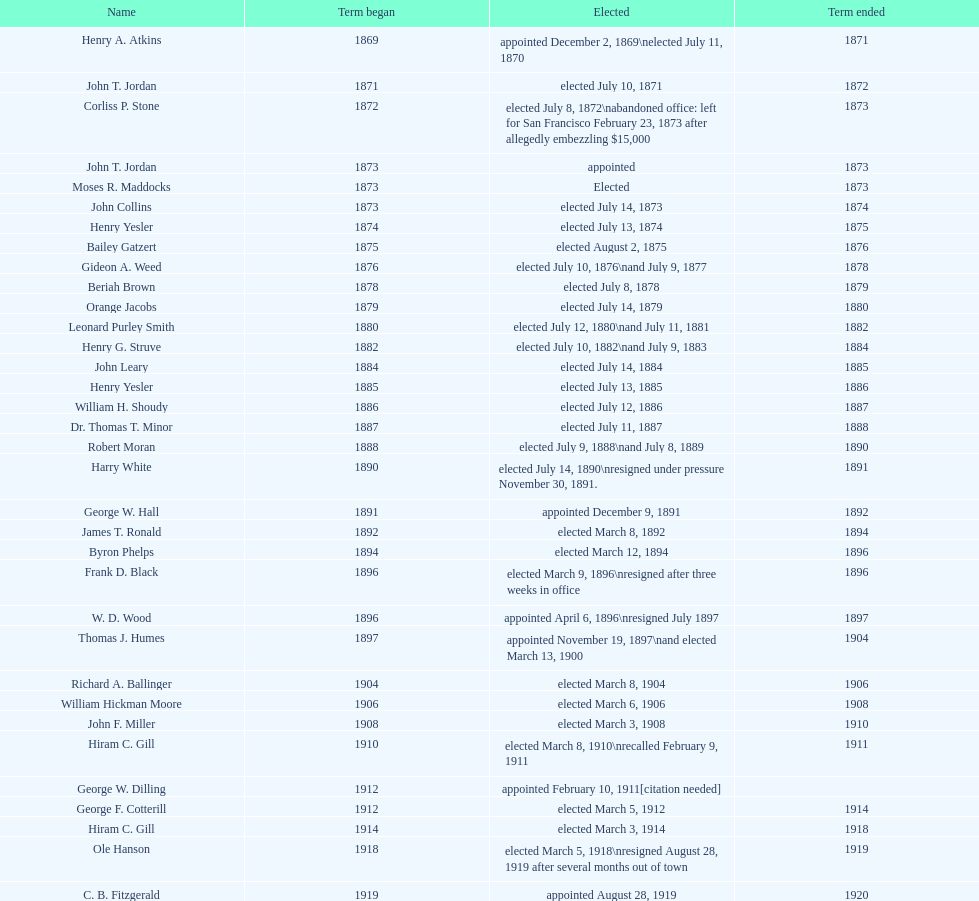Who was the mayor before jordan? Henry A. Atkins. 